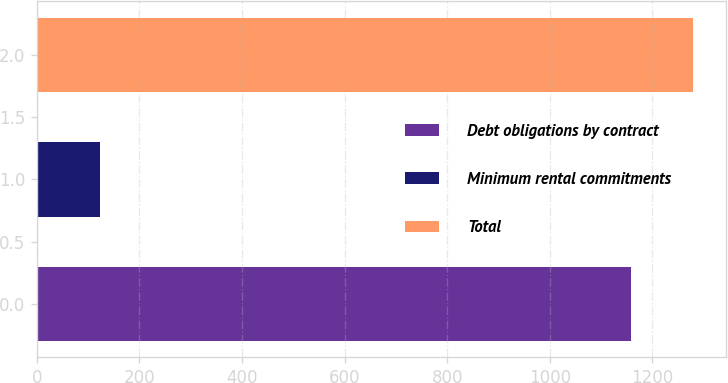<chart> <loc_0><loc_0><loc_500><loc_500><bar_chart><fcel>Debt obligations by contract<fcel>Minimum rental commitments<fcel>Total<nl><fcel>1157.5<fcel>122.5<fcel>1280<nl></chart> 